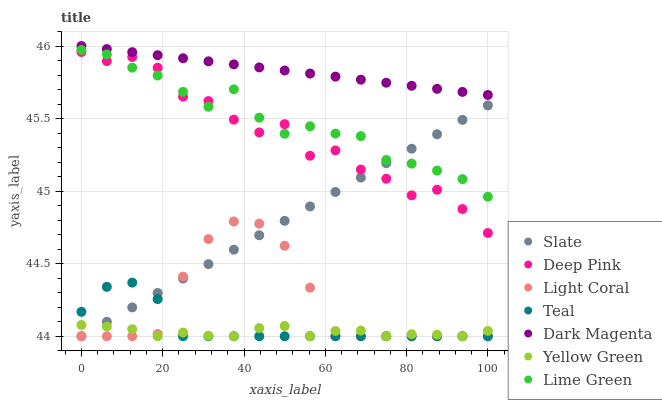Does Yellow Green have the minimum area under the curve?
Answer yes or no. Yes. Does Dark Magenta have the maximum area under the curve?
Answer yes or no. Yes. Does Slate have the minimum area under the curve?
Answer yes or no. No. Does Slate have the maximum area under the curve?
Answer yes or no. No. Is Dark Magenta the smoothest?
Answer yes or no. Yes. Is Deep Pink the roughest?
Answer yes or no. Yes. Is Slate the smoothest?
Answer yes or no. No. Is Slate the roughest?
Answer yes or no. No. Does Slate have the lowest value?
Answer yes or no. Yes. Does Dark Magenta have the lowest value?
Answer yes or no. No. Does Dark Magenta have the highest value?
Answer yes or no. Yes. Does Slate have the highest value?
Answer yes or no. No. Is Yellow Green less than Deep Pink?
Answer yes or no. Yes. Is Dark Magenta greater than Slate?
Answer yes or no. Yes. Does Yellow Green intersect Teal?
Answer yes or no. Yes. Is Yellow Green less than Teal?
Answer yes or no. No. Is Yellow Green greater than Teal?
Answer yes or no. No. Does Yellow Green intersect Deep Pink?
Answer yes or no. No. 